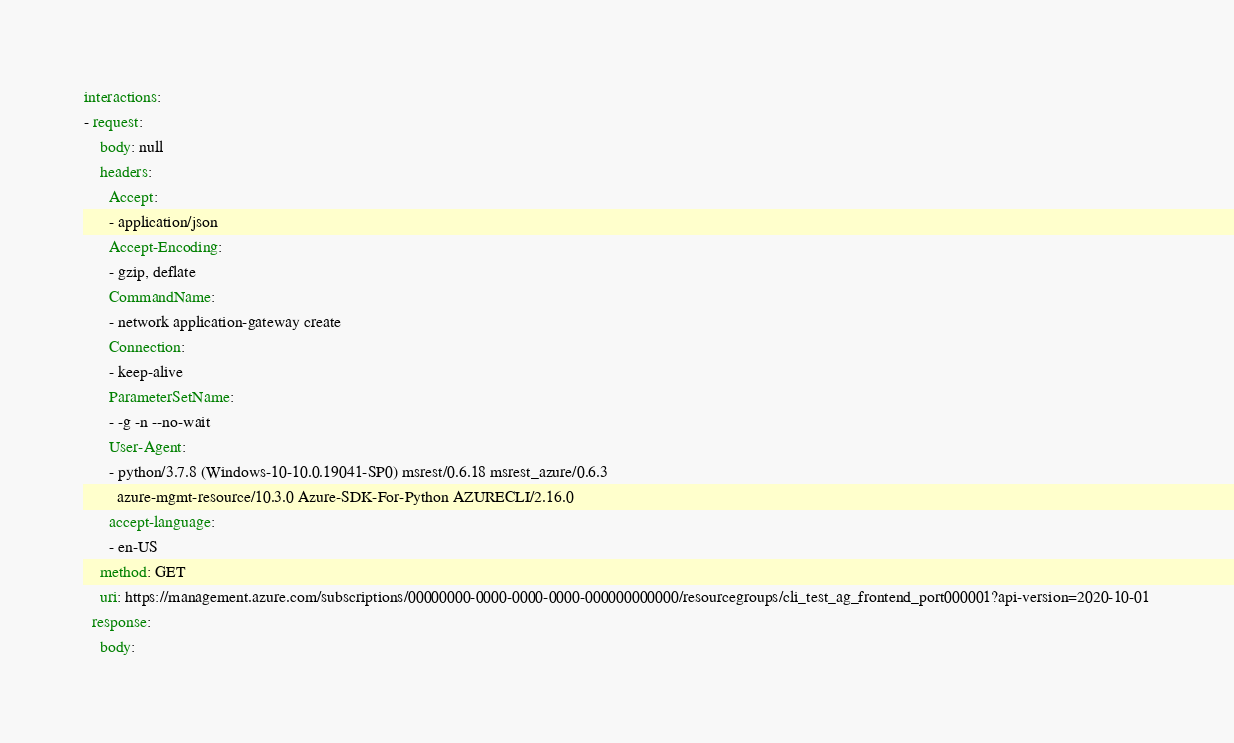Convert code to text. <code><loc_0><loc_0><loc_500><loc_500><_YAML_>interactions:
- request:
    body: null
    headers:
      Accept:
      - application/json
      Accept-Encoding:
      - gzip, deflate
      CommandName:
      - network application-gateway create
      Connection:
      - keep-alive
      ParameterSetName:
      - -g -n --no-wait
      User-Agent:
      - python/3.7.8 (Windows-10-10.0.19041-SP0) msrest/0.6.18 msrest_azure/0.6.3
        azure-mgmt-resource/10.3.0 Azure-SDK-For-Python AZURECLI/2.16.0
      accept-language:
      - en-US
    method: GET
    uri: https://management.azure.com/subscriptions/00000000-0000-0000-0000-000000000000/resourcegroups/cli_test_ag_frontend_port000001?api-version=2020-10-01
  response:
    body:</code> 